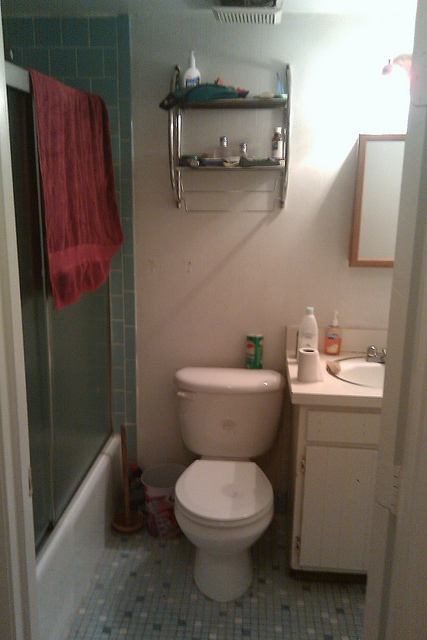What is in the container on the toilet tank? The container on the toilet tank most likely holds a substance used for personal hygiene or cleaning in the bathroom. While toothpaste, bubble bath, cleanser, and baby powder are all common bathroom items, the container's size and shape suggest it is intended for cleaning purposes. Therefore, it is reasonable to deduce that the container most likely holds a cleanser, which is typically used to maintain cleanliness and hygiene in a bathroom setting. 